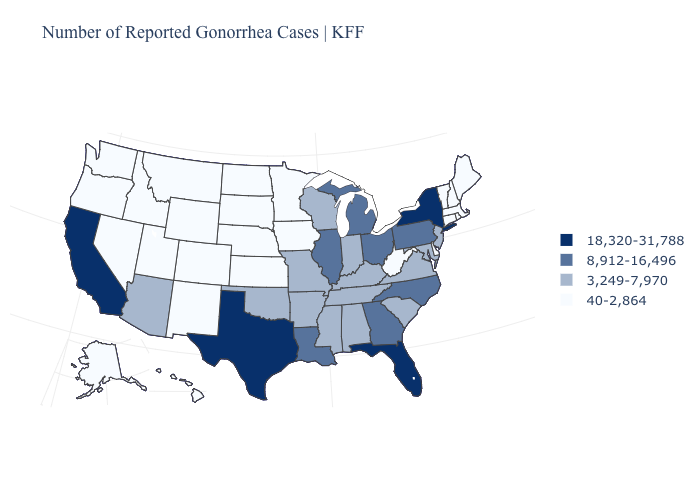What is the value of New York?
Short answer required. 18,320-31,788. Name the states that have a value in the range 40-2,864?
Answer briefly. Alaska, Colorado, Connecticut, Delaware, Hawaii, Idaho, Iowa, Kansas, Maine, Massachusetts, Minnesota, Montana, Nebraska, Nevada, New Hampshire, New Mexico, North Dakota, Oregon, Rhode Island, South Dakota, Utah, Vermont, Washington, West Virginia, Wyoming. What is the lowest value in the South?
Give a very brief answer. 40-2,864. Which states have the lowest value in the South?
Write a very short answer. Delaware, West Virginia. Among the states that border Virginia , which have the lowest value?
Keep it brief. West Virginia. Name the states that have a value in the range 3,249-7,970?
Short answer required. Alabama, Arizona, Arkansas, Indiana, Kentucky, Maryland, Mississippi, Missouri, New Jersey, Oklahoma, South Carolina, Tennessee, Virginia, Wisconsin. Name the states that have a value in the range 8,912-16,496?
Be succinct. Georgia, Illinois, Louisiana, Michigan, North Carolina, Ohio, Pennsylvania. Name the states that have a value in the range 3,249-7,970?
Keep it brief. Alabama, Arizona, Arkansas, Indiana, Kentucky, Maryland, Mississippi, Missouri, New Jersey, Oklahoma, South Carolina, Tennessee, Virginia, Wisconsin. Name the states that have a value in the range 8,912-16,496?
Short answer required. Georgia, Illinois, Louisiana, Michigan, North Carolina, Ohio, Pennsylvania. Name the states that have a value in the range 8,912-16,496?
Keep it brief. Georgia, Illinois, Louisiana, Michigan, North Carolina, Ohio, Pennsylvania. Name the states that have a value in the range 8,912-16,496?
Be succinct. Georgia, Illinois, Louisiana, Michigan, North Carolina, Ohio, Pennsylvania. Does New York have the highest value in the Northeast?
Be succinct. Yes. How many symbols are there in the legend?
Short answer required. 4. Among the states that border Mississippi , does Tennessee have the highest value?
Quick response, please. No. Name the states that have a value in the range 3,249-7,970?
Short answer required. Alabama, Arizona, Arkansas, Indiana, Kentucky, Maryland, Mississippi, Missouri, New Jersey, Oklahoma, South Carolina, Tennessee, Virginia, Wisconsin. 